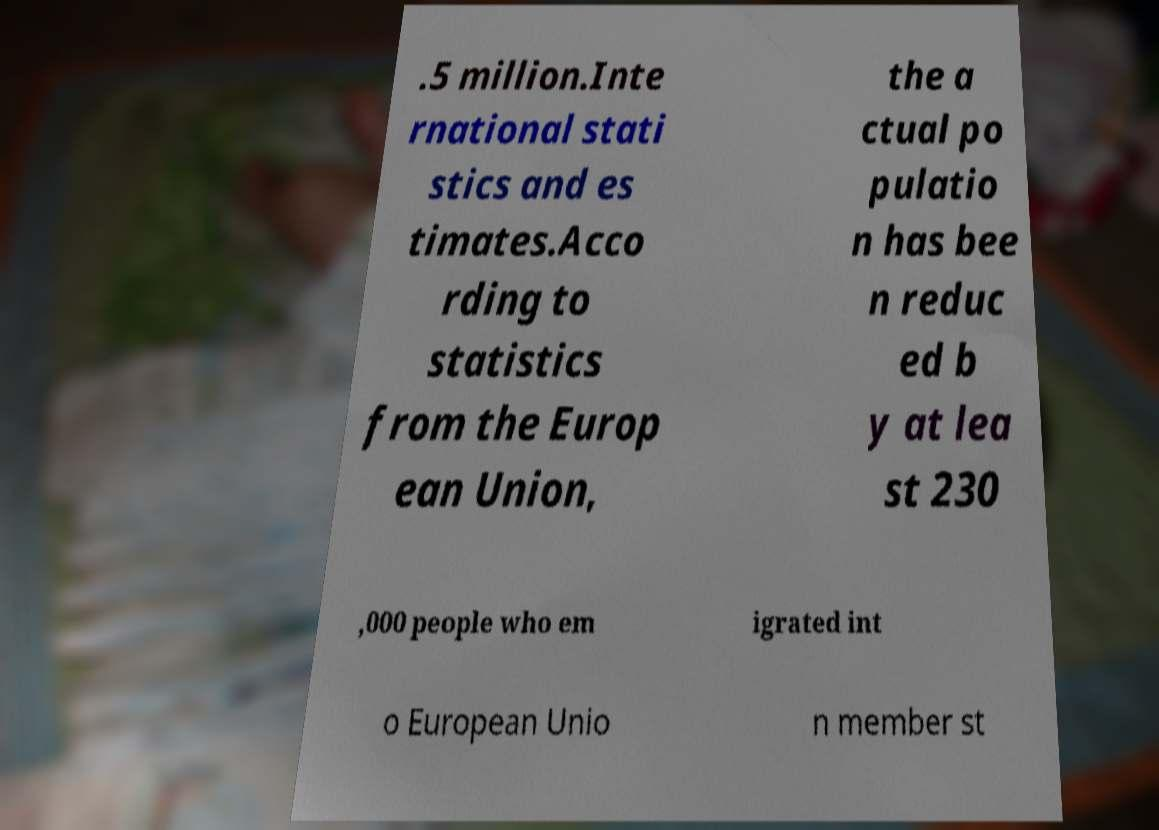Please read and relay the text visible in this image. What does it say? .5 million.Inte rnational stati stics and es timates.Acco rding to statistics from the Europ ean Union, the a ctual po pulatio n has bee n reduc ed b y at lea st 230 ,000 people who em igrated int o European Unio n member st 